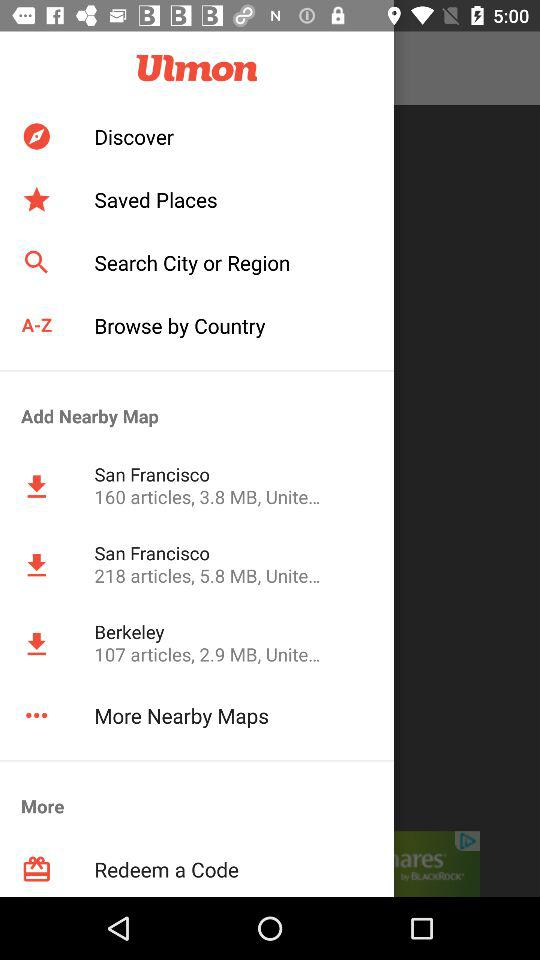What is the number of articles in San Francisco? The number of articles in San Francisco is 160. 